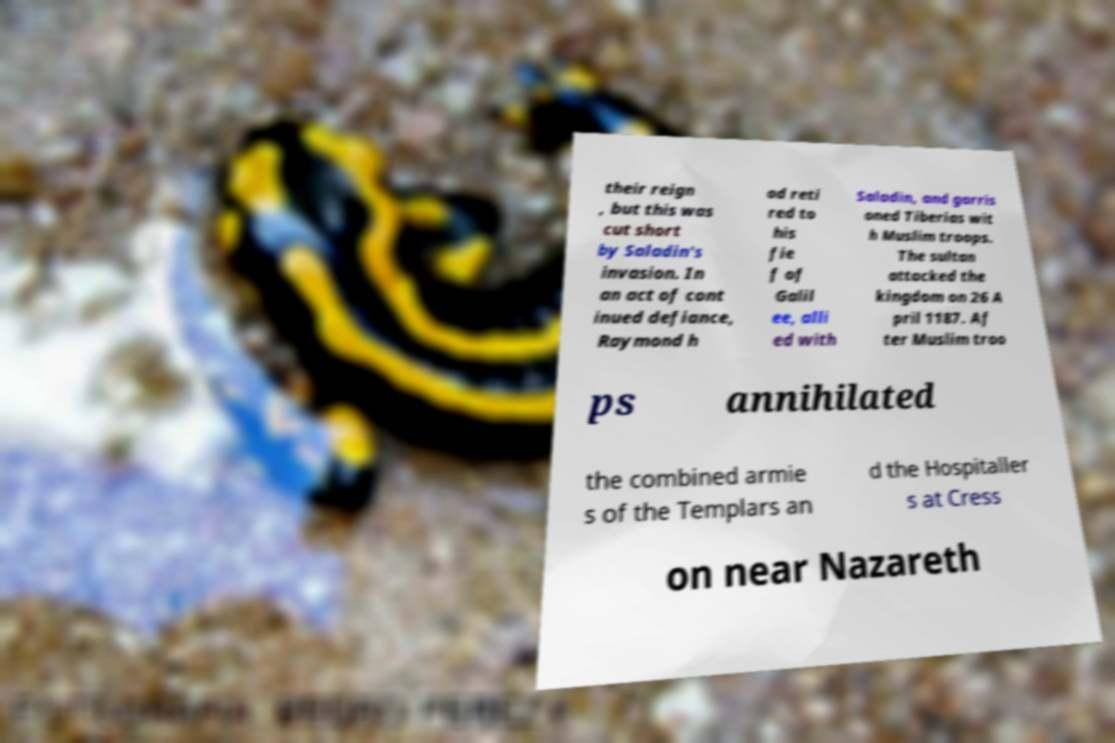I need the written content from this picture converted into text. Can you do that? their reign , but this was cut short by Saladin's invasion. In an act of cont inued defiance, Raymond h ad reti red to his fie f of Galil ee, alli ed with Saladin, and garris oned Tiberias wit h Muslim troops. The sultan attacked the kingdom on 26 A pril 1187. Af ter Muslim troo ps annihilated the combined armie s of the Templars an d the Hospitaller s at Cress on near Nazareth 